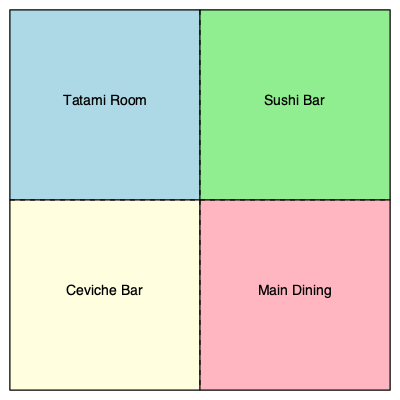In this floor plan of a Japanese-Peruvian fusion restaurant, which area best represents the cultural exchange facilitated by diplomats between Japan and Peru? To answer this question, we need to analyze the floor plan and consider the historical context of Japanese-Peruvian relations:

1. The floor plan shows four distinct areas: Tatami Room, Sushi Bar, Ceviche Bar, and Main Dining.

2. The Tatami Room represents traditional Japanese culture, while the Ceviche Bar represents traditional Peruvian culture.

3. The Sushi Bar, while originally Japanese, has become popular globally and doesn't necessarily represent the unique fusion of Japanese and Peruvian cultures.

4. The Main Dining area is likely where the fusion of both cultures is most prominent, as it would serve a variety of dishes combining Japanese and Peruvian culinary traditions.

5. Historically, Japanese migration to Peru began in the late 19th century, facilitated by diplomatic agreements between the two countries. This led to the development of Nikkei cuisine, a fusion of Japanese and Peruvian culinary traditions.

6. Diplomats played a crucial role in fostering cultural exchange and understanding between Japan and Peru, which is best represented by the fusion of both cultures in the Main Dining area.

Therefore, the area that best represents the cultural exchange facilitated by diplomats between Japan and Peru is the Main Dining area.
Answer: Main Dining area 